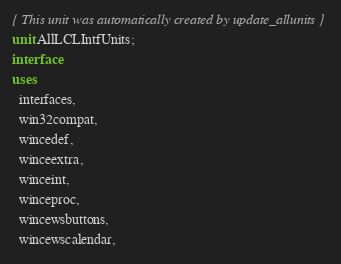<code> <loc_0><loc_0><loc_500><loc_500><_Pascal_>{ This unit was automatically created by update_allunits }
unit AllLCLIntfUnits;
interface
uses
  interfaces,
  win32compat,
  wincedef,
  winceextra,
  winceint,
  winceproc,
  wincewsbuttons,
  wincewscalendar,</code> 